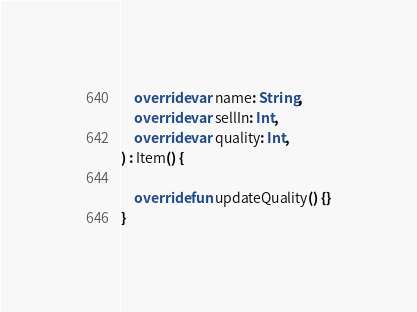<code> <loc_0><loc_0><loc_500><loc_500><_Kotlin_>    override var name: String,
    override var sellIn: Int,
    override var quality: Int,
) : Item() {

    override fun updateQuality() {}
}</code> 